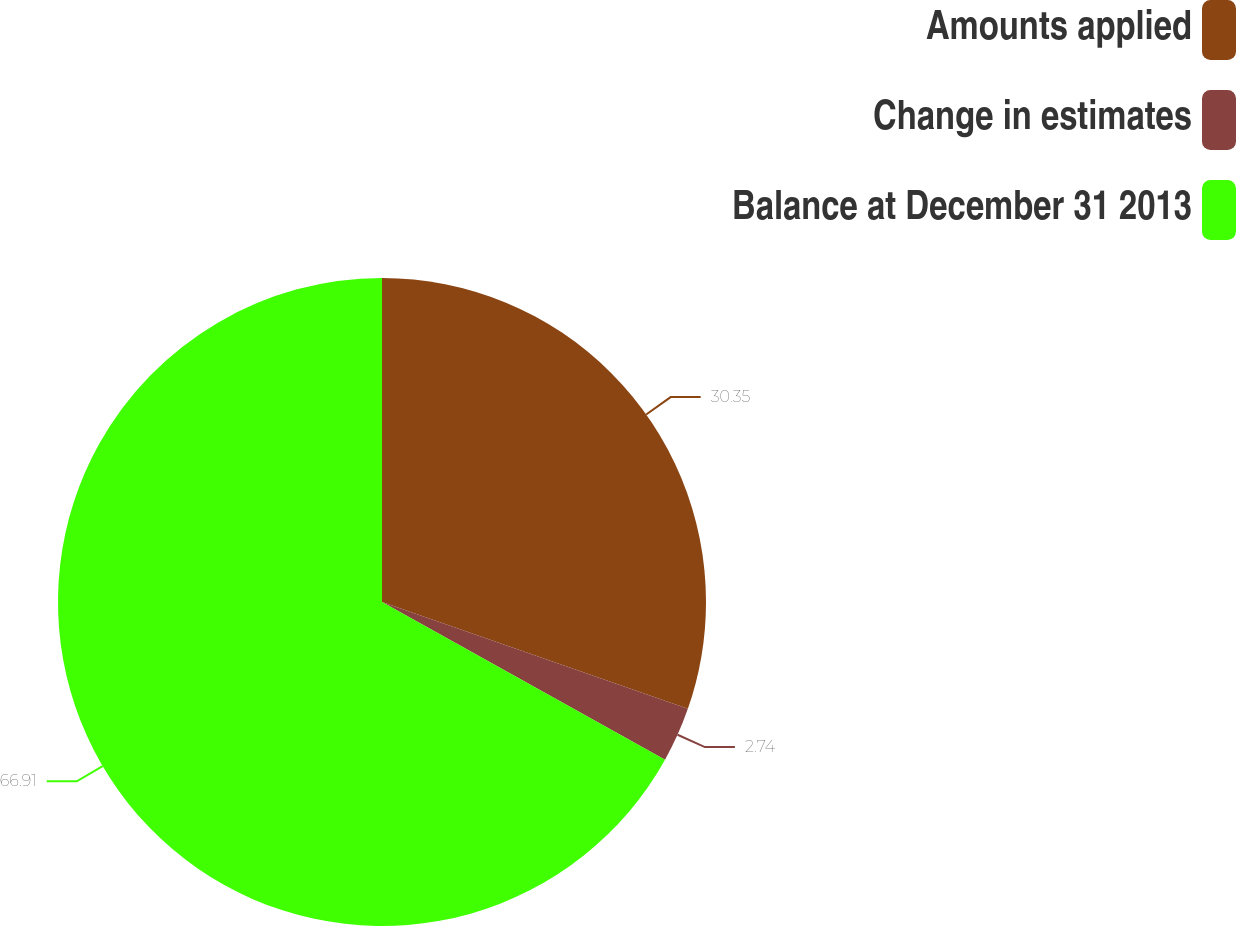Convert chart to OTSL. <chart><loc_0><loc_0><loc_500><loc_500><pie_chart><fcel>Amounts applied<fcel>Change in estimates<fcel>Balance at December 31 2013<nl><fcel>30.35%<fcel>2.74%<fcel>66.91%<nl></chart> 